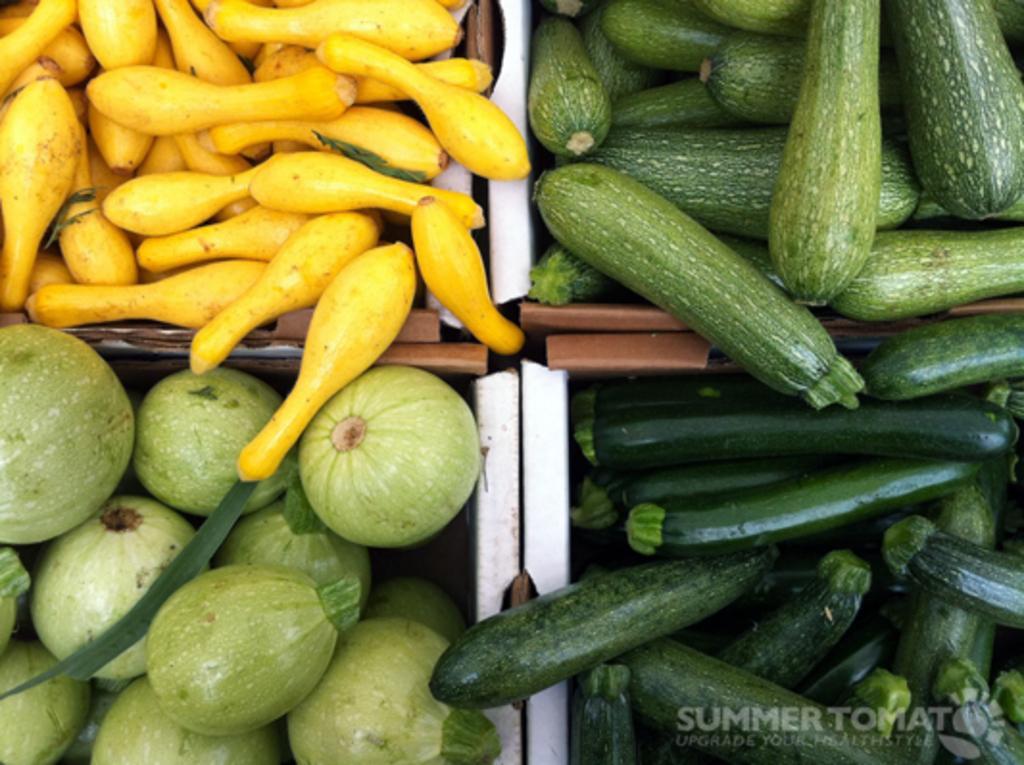Can you describe this image briefly? In the center of the image we can see different types of vegetables in the baskets. At the bottom right side of the image, there is a watermark. 